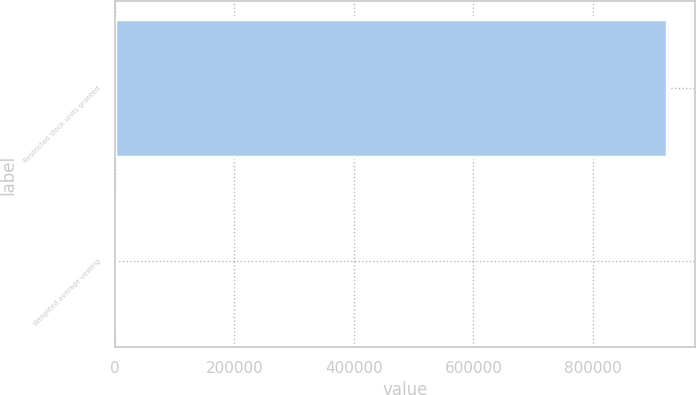<chart> <loc_0><loc_0><loc_500><loc_500><bar_chart><fcel>Restricted stock units granted<fcel>Weighted average vesting<nl><fcel>924576<fcel>3<nl></chart> 